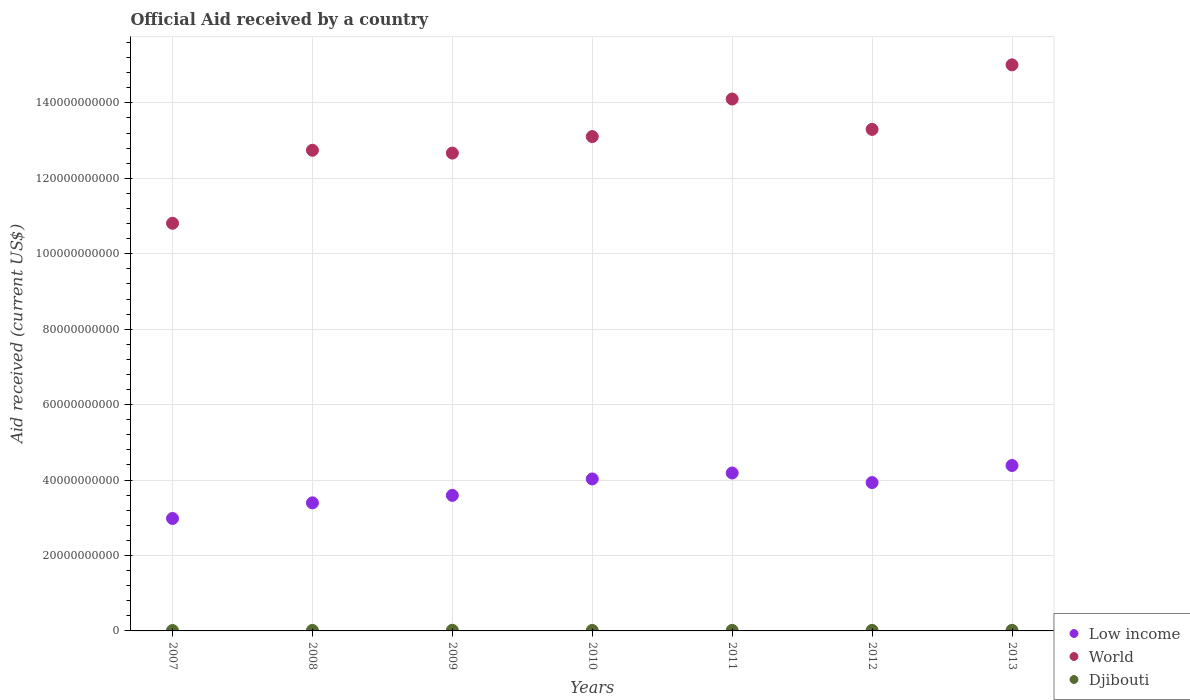How many different coloured dotlines are there?
Make the answer very short. 3. Is the number of dotlines equal to the number of legend labels?
Give a very brief answer. Yes. What is the net official aid received in World in 2012?
Provide a succinct answer. 1.33e+11. Across all years, what is the maximum net official aid received in World?
Your answer should be very brief. 1.50e+11. Across all years, what is the minimum net official aid received in Low income?
Your answer should be compact. 2.98e+1. What is the total net official aid received in World in the graph?
Offer a terse response. 9.17e+11. What is the difference between the net official aid received in World in 2008 and that in 2009?
Your response must be concise. 7.53e+08. What is the difference between the net official aid received in Djibouti in 2011 and the net official aid received in World in 2008?
Give a very brief answer. -1.27e+11. What is the average net official aid received in Djibouti per year?
Make the answer very short. 1.42e+08. In the year 2007, what is the difference between the net official aid received in Low income and net official aid received in Djibouti?
Offer a terse response. 2.97e+1. What is the ratio of the net official aid received in Low income in 2008 to that in 2009?
Your response must be concise. 0.94. Is the difference between the net official aid received in Low income in 2008 and 2012 greater than the difference between the net official aid received in Djibouti in 2008 and 2012?
Keep it short and to the point. No. What is the difference between the highest and the second highest net official aid received in World?
Provide a succinct answer. 9.06e+09. What is the difference between the highest and the lowest net official aid received in Low income?
Make the answer very short. 1.40e+1. Is the sum of the net official aid received in World in 2008 and 2011 greater than the maximum net official aid received in Low income across all years?
Your response must be concise. Yes. Is it the case that in every year, the sum of the net official aid received in Djibouti and net official aid received in Low income  is greater than the net official aid received in World?
Offer a very short reply. No. Is the net official aid received in Djibouti strictly greater than the net official aid received in World over the years?
Ensure brevity in your answer.  No. Is the net official aid received in Djibouti strictly less than the net official aid received in World over the years?
Give a very brief answer. Yes. How many dotlines are there?
Keep it short and to the point. 3. Are the values on the major ticks of Y-axis written in scientific E-notation?
Your answer should be compact. No. Does the graph contain any zero values?
Keep it short and to the point. No. Does the graph contain grids?
Provide a short and direct response. Yes. What is the title of the graph?
Your answer should be compact. Official Aid received by a country. Does "India" appear as one of the legend labels in the graph?
Offer a very short reply. No. What is the label or title of the X-axis?
Ensure brevity in your answer.  Years. What is the label or title of the Y-axis?
Offer a very short reply. Aid received (current US$). What is the Aid received (current US$) in Low income in 2007?
Keep it short and to the point. 2.98e+1. What is the Aid received (current US$) of World in 2007?
Make the answer very short. 1.08e+11. What is the Aid received (current US$) in Djibouti in 2007?
Your response must be concise. 1.13e+08. What is the Aid received (current US$) of Low income in 2008?
Keep it short and to the point. 3.40e+1. What is the Aid received (current US$) of World in 2008?
Keep it short and to the point. 1.27e+11. What is the Aid received (current US$) in Djibouti in 2008?
Offer a terse response. 1.41e+08. What is the Aid received (current US$) in Low income in 2009?
Provide a short and direct response. 3.59e+1. What is the Aid received (current US$) of World in 2009?
Offer a very short reply. 1.27e+11. What is the Aid received (current US$) in Djibouti in 2009?
Offer a terse response. 1.67e+08. What is the Aid received (current US$) of Low income in 2010?
Offer a very short reply. 4.03e+1. What is the Aid received (current US$) in World in 2010?
Provide a succinct answer. 1.31e+11. What is the Aid received (current US$) of Djibouti in 2010?
Keep it short and to the point. 1.32e+08. What is the Aid received (current US$) of Low income in 2011?
Offer a very short reply. 4.19e+1. What is the Aid received (current US$) in World in 2011?
Provide a short and direct response. 1.41e+11. What is the Aid received (current US$) of Djibouti in 2011?
Your response must be concise. 1.42e+08. What is the Aid received (current US$) in Low income in 2012?
Offer a terse response. 3.93e+1. What is the Aid received (current US$) of World in 2012?
Provide a short and direct response. 1.33e+11. What is the Aid received (current US$) in Djibouti in 2012?
Offer a terse response. 1.47e+08. What is the Aid received (current US$) of Low income in 2013?
Offer a very short reply. 4.39e+1. What is the Aid received (current US$) in World in 2013?
Provide a short and direct response. 1.50e+11. What is the Aid received (current US$) in Djibouti in 2013?
Offer a terse response. 1.53e+08. Across all years, what is the maximum Aid received (current US$) in Low income?
Provide a succinct answer. 4.39e+1. Across all years, what is the maximum Aid received (current US$) of World?
Your answer should be very brief. 1.50e+11. Across all years, what is the maximum Aid received (current US$) in Djibouti?
Keep it short and to the point. 1.67e+08. Across all years, what is the minimum Aid received (current US$) in Low income?
Ensure brevity in your answer.  2.98e+1. Across all years, what is the minimum Aid received (current US$) in World?
Provide a short and direct response. 1.08e+11. Across all years, what is the minimum Aid received (current US$) of Djibouti?
Provide a short and direct response. 1.13e+08. What is the total Aid received (current US$) of Low income in the graph?
Make the answer very short. 2.65e+11. What is the total Aid received (current US$) in World in the graph?
Your answer should be very brief. 9.17e+11. What is the total Aid received (current US$) in Djibouti in the graph?
Provide a succinct answer. 9.94e+08. What is the difference between the Aid received (current US$) of Low income in 2007 and that in 2008?
Your answer should be compact. -4.14e+09. What is the difference between the Aid received (current US$) of World in 2007 and that in 2008?
Your response must be concise. -1.94e+1. What is the difference between the Aid received (current US$) of Djibouti in 2007 and that in 2008?
Offer a terse response. -2.82e+07. What is the difference between the Aid received (current US$) of Low income in 2007 and that in 2009?
Give a very brief answer. -6.13e+09. What is the difference between the Aid received (current US$) in World in 2007 and that in 2009?
Your response must be concise. -1.86e+1. What is the difference between the Aid received (current US$) of Djibouti in 2007 and that in 2009?
Make the answer very short. -5.41e+07. What is the difference between the Aid received (current US$) in Low income in 2007 and that in 2010?
Offer a terse response. -1.05e+1. What is the difference between the Aid received (current US$) of World in 2007 and that in 2010?
Your answer should be compact. -2.30e+1. What is the difference between the Aid received (current US$) of Djibouti in 2007 and that in 2010?
Provide a succinct answer. -1.96e+07. What is the difference between the Aid received (current US$) in Low income in 2007 and that in 2011?
Provide a succinct answer. -1.21e+1. What is the difference between the Aid received (current US$) in World in 2007 and that in 2011?
Give a very brief answer. -3.29e+1. What is the difference between the Aid received (current US$) of Djibouti in 2007 and that in 2011?
Keep it short and to the point. -2.91e+07. What is the difference between the Aid received (current US$) of Low income in 2007 and that in 2012?
Provide a succinct answer. -9.52e+09. What is the difference between the Aid received (current US$) of World in 2007 and that in 2012?
Provide a short and direct response. -2.49e+1. What is the difference between the Aid received (current US$) of Djibouti in 2007 and that in 2012?
Offer a very short reply. -3.40e+07. What is the difference between the Aid received (current US$) of Low income in 2007 and that in 2013?
Your answer should be compact. -1.40e+1. What is the difference between the Aid received (current US$) in World in 2007 and that in 2013?
Offer a terse response. -4.20e+1. What is the difference between the Aid received (current US$) in Djibouti in 2007 and that in 2013?
Your response must be concise. -4.03e+07. What is the difference between the Aid received (current US$) in Low income in 2008 and that in 2009?
Make the answer very short. -1.98e+09. What is the difference between the Aid received (current US$) of World in 2008 and that in 2009?
Keep it short and to the point. 7.53e+08. What is the difference between the Aid received (current US$) in Djibouti in 2008 and that in 2009?
Offer a terse response. -2.59e+07. What is the difference between the Aid received (current US$) of Low income in 2008 and that in 2010?
Offer a terse response. -6.34e+09. What is the difference between the Aid received (current US$) in World in 2008 and that in 2010?
Keep it short and to the point. -3.63e+09. What is the difference between the Aid received (current US$) of Djibouti in 2008 and that in 2010?
Give a very brief answer. 8.58e+06. What is the difference between the Aid received (current US$) in Low income in 2008 and that in 2011?
Provide a short and direct response. -7.92e+09. What is the difference between the Aid received (current US$) of World in 2008 and that in 2011?
Your response must be concise. -1.36e+1. What is the difference between the Aid received (current US$) in Djibouti in 2008 and that in 2011?
Ensure brevity in your answer.  -9.30e+05. What is the difference between the Aid received (current US$) in Low income in 2008 and that in 2012?
Ensure brevity in your answer.  -5.38e+09. What is the difference between the Aid received (current US$) of World in 2008 and that in 2012?
Ensure brevity in your answer.  -5.53e+09. What is the difference between the Aid received (current US$) in Djibouti in 2008 and that in 2012?
Your answer should be compact. -5.77e+06. What is the difference between the Aid received (current US$) of Low income in 2008 and that in 2013?
Provide a succinct answer. -9.90e+09. What is the difference between the Aid received (current US$) in World in 2008 and that in 2013?
Provide a succinct answer. -2.26e+1. What is the difference between the Aid received (current US$) in Djibouti in 2008 and that in 2013?
Your answer should be compact. -1.21e+07. What is the difference between the Aid received (current US$) in Low income in 2009 and that in 2010?
Offer a very short reply. -4.36e+09. What is the difference between the Aid received (current US$) in World in 2009 and that in 2010?
Provide a succinct answer. -4.38e+09. What is the difference between the Aid received (current US$) of Djibouti in 2009 and that in 2010?
Ensure brevity in your answer.  3.45e+07. What is the difference between the Aid received (current US$) in Low income in 2009 and that in 2011?
Ensure brevity in your answer.  -5.94e+09. What is the difference between the Aid received (current US$) of World in 2009 and that in 2011?
Offer a very short reply. -1.43e+1. What is the difference between the Aid received (current US$) in Djibouti in 2009 and that in 2011?
Offer a very short reply. 2.50e+07. What is the difference between the Aid received (current US$) of Low income in 2009 and that in 2012?
Your answer should be compact. -3.39e+09. What is the difference between the Aid received (current US$) in World in 2009 and that in 2012?
Offer a terse response. -6.29e+09. What is the difference between the Aid received (current US$) in Djibouti in 2009 and that in 2012?
Offer a very short reply. 2.01e+07. What is the difference between the Aid received (current US$) of Low income in 2009 and that in 2013?
Make the answer very short. -7.92e+09. What is the difference between the Aid received (current US$) in World in 2009 and that in 2013?
Provide a short and direct response. -2.34e+1. What is the difference between the Aid received (current US$) of Djibouti in 2009 and that in 2013?
Provide a short and direct response. 1.38e+07. What is the difference between the Aid received (current US$) of Low income in 2010 and that in 2011?
Offer a terse response. -1.58e+09. What is the difference between the Aid received (current US$) of World in 2010 and that in 2011?
Your answer should be very brief. -9.96e+09. What is the difference between the Aid received (current US$) of Djibouti in 2010 and that in 2011?
Your answer should be very brief. -9.51e+06. What is the difference between the Aid received (current US$) of Low income in 2010 and that in 2012?
Give a very brief answer. 9.64e+08. What is the difference between the Aid received (current US$) in World in 2010 and that in 2012?
Your answer should be compact. -1.91e+09. What is the difference between the Aid received (current US$) of Djibouti in 2010 and that in 2012?
Ensure brevity in your answer.  -1.44e+07. What is the difference between the Aid received (current US$) of Low income in 2010 and that in 2013?
Your answer should be compact. -3.56e+09. What is the difference between the Aid received (current US$) of World in 2010 and that in 2013?
Your answer should be compact. -1.90e+1. What is the difference between the Aid received (current US$) in Djibouti in 2010 and that in 2013?
Your response must be concise. -2.07e+07. What is the difference between the Aid received (current US$) of Low income in 2011 and that in 2012?
Offer a very short reply. 2.54e+09. What is the difference between the Aid received (current US$) in World in 2011 and that in 2012?
Keep it short and to the point. 8.05e+09. What is the difference between the Aid received (current US$) of Djibouti in 2011 and that in 2012?
Keep it short and to the point. -4.84e+06. What is the difference between the Aid received (current US$) of Low income in 2011 and that in 2013?
Offer a terse response. -1.98e+09. What is the difference between the Aid received (current US$) of World in 2011 and that in 2013?
Provide a short and direct response. -9.06e+09. What is the difference between the Aid received (current US$) in Djibouti in 2011 and that in 2013?
Provide a succinct answer. -1.12e+07. What is the difference between the Aid received (current US$) in Low income in 2012 and that in 2013?
Provide a short and direct response. -4.52e+09. What is the difference between the Aid received (current US$) of World in 2012 and that in 2013?
Provide a succinct answer. -1.71e+1. What is the difference between the Aid received (current US$) of Djibouti in 2012 and that in 2013?
Offer a very short reply. -6.36e+06. What is the difference between the Aid received (current US$) in Low income in 2007 and the Aid received (current US$) in World in 2008?
Keep it short and to the point. -9.76e+1. What is the difference between the Aid received (current US$) in Low income in 2007 and the Aid received (current US$) in Djibouti in 2008?
Make the answer very short. 2.97e+1. What is the difference between the Aid received (current US$) in World in 2007 and the Aid received (current US$) in Djibouti in 2008?
Offer a terse response. 1.08e+11. What is the difference between the Aid received (current US$) of Low income in 2007 and the Aid received (current US$) of World in 2009?
Your answer should be very brief. -9.69e+1. What is the difference between the Aid received (current US$) of Low income in 2007 and the Aid received (current US$) of Djibouti in 2009?
Make the answer very short. 2.96e+1. What is the difference between the Aid received (current US$) of World in 2007 and the Aid received (current US$) of Djibouti in 2009?
Offer a terse response. 1.08e+11. What is the difference between the Aid received (current US$) in Low income in 2007 and the Aid received (current US$) in World in 2010?
Your answer should be compact. -1.01e+11. What is the difference between the Aid received (current US$) in Low income in 2007 and the Aid received (current US$) in Djibouti in 2010?
Provide a short and direct response. 2.97e+1. What is the difference between the Aid received (current US$) in World in 2007 and the Aid received (current US$) in Djibouti in 2010?
Offer a terse response. 1.08e+11. What is the difference between the Aid received (current US$) of Low income in 2007 and the Aid received (current US$) of World in 2011?
Offer a terse response. -1.11e+11. What is the difference between the Aid received (current US$) in Low income in 2007 and the Aid received (current US$) in Djibouti in 2011?
Your response must be concise. 2.97e+1. What is the difference between the Aid received (current US$) in World in 2007 and the Aid received (current US$) in Djibouti in 2011?
Provide a short and direct response. 1.08e+11. What is the difference between the Aid received (current US$) of Low income in 2007 and the Aid received (current US$) of World in 2012?
Offer a terse response. -1.03e+11. What is the difference between the Aid received (current US$) of Low income in 2007 and the Aid received (current US$) of Djibouti in 2012?
Your answer should be very brief. 2.97e+1. What is the difference between the Aid received (current US$) of World in 2007 and the Aid received (current US$) of Djibouti in 2012?
Keep it short and to the point. 1.08e+11. What is the difference between the Aid received (current US$) in Low income in 2007 and the Aid received (current US$) in World in 2013?
Provide a short and direct response. -1.20e+11. What is the difference between the Aid received (current US$) in Low income in 2007 and the Aid received (current US$) in Djibouti in 2013?
Ensure brevity in your answer.  2.97e+1. What is the difference between the Aid received (current US$) of World in 2007 and the Aid received (current US$) of Djibouti in 2013?
Ensure brevity in your answer.  1.08e+11. What is the difference between the Aid received (current US$) in Low income in 2008 and the Aid received (current US$) in World in 2009?
Offer a terse response. -9.27e+1. What is the difference between the Aid received (current US$) in Low income in 2008 and the Aid received (current US$) in Djibouti in 2009?
Make the answer very short. 3.38e+1. What is the difference between the Aid received (current US$) of World in 2008 and the Aid received (current US$) of Djibouti in 2009?
Your answer should be very brief. 1.27e+11. What is the difference between the Aid received (current US$) of Low income in 2008 and the Aid received (current US$) of World in 2010?
Your response must be concise. -9.71e+1. What is the difference between the Aid received (current US$) of Low income in 2008 and the Aid received (current US$) of Djibouti in 2010?
Make the answer very short. 3.38e+1. What is the difference between the Aid received (current US$) in World in 2008 and the Aid received (current US$) in Djibouti in 2010?
Make the answer very short. 1.27e+11. What is the difference between the Aid received (current US$) in Low income in 2008 and the Aid received (current US$) in World in 2011?
Your response must be concise. -1.07e+11. What is the difference between the Aid received (current US$) in Low income in 2008 and the Aid received (current US$) in Djibouti in 2011?
Provide a short and direct response. 3.38e+1. What is the difference between the Aid received (current US$) in World in 2008 and the Aid received (current US$) in Djibouti in 2011?
Keep it short and to the point. 1.27e+11. What is the difference between the Aid received (current US$) of Low income in 2008 and the Aid received (current US$) of World in 2012?
Offer a very short reply. -9.90e+1. What is the difference between the Aid received (current US$) in Low income in 2008 and the Aid received (current US$) in Djibouti in 2012?
Your response must be concise. 3.38e+1. What is the difference between the Aid received (current US$) of World in 2008 and the Aid received (current US$) of Djibouti in 2012?
Your answer should be compact. 1.27e+11. What is the difference between the Aid received (current US$) in Low income in 2008 and the Aid received (current US$) in World in 2013?
Ensure brevity in your answer.  -1.16e+11. What is the difference between the Aid received (current US$) in Low income in 2008 and the Aid received (current US$) in Djibouti in 2013?
Keep it short and to the point. 3.38e+1. What is the difference between the Aid received (current US$) in World in 2008 and the Aid received (current US$) in Djibouti in 2013?
Make the answer very short. 1.27e+11. What is the difference between the Aid received (current US$) in Low income in 2009 and the Aid received (current US$) in World in 2010?
Ensure brevity in your answer.  -9.51e+1. What is the difference between the Aid received (current US$) in Low income in 2009 and the Aid received (current US$) in Djibouti in 2010?
Offer a terse response. 3.58e+1. What is the difference between the Aid received (current US$) in World in 2009 and the Aid received (current US$) in Djibouti in 2010?
Ensure brevity in your answer.  1.27e+11. What is the difference between the Aid received (current US$) in Low income in 2009 and the Aid received (current US$) in World in 2011?
Provide a succinct answer. -1.05e+11. What is the difference between the Aid received (current US$) in Low income in 2009 and the Aid received (current US$) in Djibouti in 2011?
Make the answer very short. 3.58e+1. What is the difference between the Aid received (current US$) of World in 2009 and the Aid received (current US$) of Djibouti in 2011?
Provide a succinct answer. 1.27e+11. What is the difference between the Aid received (current US$) in Low income in 2009 and the Aid received (current US$) in World in 2012?
Give a very brief answer. -9.70e+1. What is the difference between the Aid received (current US$) of Low income in 2009 and the Aid received (current US$) of Djibouti in 2012?
Your answer should be compact. 3.58e+1. What is the difference between the Aid received (current US$) of World in 2009 and the Aid received (current US$) of Djibouti in 2012?
Provide a succinct answer. 1.27e+11. What is the difference between the Aid received (current US$) of Low income in 2009 and the Aid received (current US$) of World in 2013?
Give a very brief answer. -1.14e+11. What is the difference between the Aid received (current US$) in Low income in 2009 and the Aid received (current US$) in Djibouti in 2013?
Your answer should be very brief. 3.58e+1. What is the difference between the Aid received (current US$) in World in 2009 and the Aid received (current US$) in Djibouti in 2013?
Provide a succinct answer. 1.27e+11. What is the difference between the Aid received (current US$) in Low income in 2010 and the Aid received (current US$) in World in 2011?
Ensure brevity in your answer.  -1.01e+11. What is the difference between the Aid received (current US$) in Low income in 2010 and the Aid received (current US$) in Djibouti in 2011?
Your answer should be compact. 4.02e+1. What is the difference between the Aid received (current US$) of World in 2010 and the Aid received (current US$) of Djibouti in 2011?
Your response must be concise. 1.31e+11. What is the difference between the Aid received (current US$) of Low income in 2010 and the Aid received (current US$) of World in 2012?
Keep it short and to the point. -9.27e+1. What is the difference between the Aid received (current US$) in Low income in 2010 and the Aid received (current US$) in Djibouti in 2012?
Your answer should be very brief. 4.02e+1. What is the difference between the Aid received (current US$) of World in 2010 and the Aid received (current US$) of Djibouti in 2012?
Ensure brevity in your answer.  1.31e+11. What is the difference between the Aid received (current US$) in Low income in 2010 and the Aid received (current US$) in World in 2013?
Make the answer very short. -1.10e+11. What is the difference between the Aid received (current US$) of Low income in 2010 and the Aid received (current US$) of Djibouti in 2013?
Your response must be concise. 4.01e+1. What is the difference between the Aid received (current US$) in World in 2010 and the Aid received (current US$) in Djibouti in 2013?
Keep it short and to the point. 1.31e+11. What is the difference between the Aid received (current US$) of Low income in 2011 and the Aid received (current US$) of World in 2012?
Ensure brevity in your answer.  -9.11e+1. What is the difference between the Aid received (current US$) in Low income in 2011 and the Aid received (current US$) in Djibouti in 2012?
Your answer should be compact. 4.17e+1. What is the difference between the Aid received (current US$) in World in 2011 and the Aid received (current US$) in Djibouti in 2012?
Keep it short and to the point. 1.41e+11. What is the difference between the Aid received (current US$) of Low income in 2011 and the Aid received (current US$) of World in 2013?
Ensure brevity in your answer.  -1.08e+11. What is the difference between the Aid received (current US$) of Low income in 2011 and the Aid received (current US$) of Djibouti in 2013?
Offer a very short reply. 4.17e+1. What is the difference between the Aid received (current US$) of World in 2011 and the Aid received (current US$) of Djibouti in 2013?
Give a very brief answer. 1.41e+11. What is the difference between the Aid received (current US$) of Low income in 2012 and the Aid received (current US$) of World in 2013?
Your answer should be compact. -1.11e+11. What is the difference between the Aid received (current US$) in Low income in 2012 and the Aid received (current US$) in Djibouti in 2013?
Give a very brief answer. 3.92e+1. What is the difference between the Aid received (current US$) in World in 2012 and the Aid received (current US$) in Djibouti in 2013?
Ensure brevity in your answer.  1.33e+11. What is the average Aid received (current US$) of Low income per year?
Provide a succinct answer. 3.79e+1. What is the average Aid received (current US$) of World per year?
Your answer should be compact. 1.31e+11. What is the average Aid received (current US$) of Djibouti per year?
Your response must be concise. 1.42e+08. In the year 2007, what is the difference between the Aid received (current US$) in Low income and Aid received (current US$) in World?
Offer a terse response. -7.83e+1. In the year 2007, what is the difference between the Aid received (current US$) in Low income and Aid received (current US$) in Djibouti?
Your answer should be very brief. 2.97e+1. In the year 2007, what is the difference between the Aid received (current US$) of World and Aid received (current US$) of Djibouti?
Provide a short and direct response. 1.08e+11. In the year 2008, what is the difference between the Aid received (current US$) of Low income and Aid received (current US$) of World?
Give a very brief answer. -9.35e+1. In the year 2008, what is the difference between the Aid received (current US$) of Low income and Aid received (current US$) of Djibouti?
Give a very brief answer. 3.38e+1. In the year 2008, what is the difference between the Aid received (current US$) of World and Aid received (current US$) of Djibouti?
Provide a short and direct response. 1.27e+11. In the year 2009, what is the difference between the Aid received (current US$) in Low income and Aid received (current US$) in World?
Your response must be concise. -9.08e+1. In the year 2009, what is the difference between the Aid received (current US$) in Low income and Aid received (current US$) in Djibouti?
Keep it short and to the point. 3.58e+1. In the year 2009, what is the difference between the Aid received (current US$) in World and Aid received (current US$) in Djibouti?
Provide a short and direct response. 1.27e+11. In the year 2010, what is the difference between the Aid received (current US$) of Low income and Aid received (current US$) of World?
Offer a terse response. -9.08e+1. In the year 2010, what is the difference between the Aid received (current US$) of Low income and Aid received (current US$) of Djibouti?
Give a very brief answer. 4.02e+1. In the year 2010, what is the difference between the Aid received (current US$) in World and Aid received (current US$) in Djibouti?
Ensure brevity in your answer.  1.31e+11. In the year 2011, what is the difference between the Aid received (current US$) of Low income and Aid received (current US$) of World?
Your answer should be compact. -9.92e+1. In the year 2011, what is the difference between the Aid received (current US$) of Low income and Aid received (current US$) of Djibouti?
Provide a succinct answer. 4.17e+1. In the year 2011, what is the difference between the Aid received (current US$) of World and Aid received (current US$) of Djibouti?
Keep it short and to the point. 1.41e+11. In the year 2012, what is the difference between the Aid received (current US$) of Low income and Aid received (current US$) of World?
Keep it short and to the point. -9.36e+1. In the year 2012, what is the difference between the Aid received (current US$) in Low income and Aid received (current US$) in Djibouti?
Your answer should be very brief. 3.92e+1. In the year 2012, what is the difference between the Aid received (current US$) of World and Aid received (current US$) of Djibouti?
Ensure brevity in your answer.  1.33e+11. In the year 2013, what is the difference between the Aid received (current US$) of Low income and Aid received (current US$) of World?
Offer a very short reply. -1.06e+11. In the year 2013, what is the difference between the Aid received (current US$) in Low income and Aid received (current US$) in Djibouti?
Your response must be concise. 4.37e+1. In the year 2013, what is the difference between the Aid received (current US$) of World and Aid received (current US$) of Djibouti?
Your answer should be very brief. 1.50e+11. What is the ratio of the Aid received (current US$) in Low income in 2007 to that in 2008?
Your response must be concise. 0.88. What is the ratio of the Aid received (current US$) of World in 2007 to that in 2008?
Your response must be concise. 0.85. What is the ratio of the Aid received (current US$) of Djibouti in 2007 to that in 2008?
Provide a succinct answer. 0.8. What is the ratio of the Aid received (current US$) in Low income in 2007 to that in 2009?
Your answer should be compact. 0.83. What is the ratio of the Aid received (current US$) in World in 2007 to that in 2009?
Ensure brevity in your answer.  0.85. What is the ratio of the Aid received (current US$) of Djibouti in 2007 to that in 2009?
Your answer should be compact. 0.68. What is the ratio of the Aid received (current US$) of Low income in 2007 to that in 2010?
Provide a succinct answer. 0.74. What is the ratio of the Aid received (current US$) in World in 2007 to that in 2010?
Keep it short and to the point. 0.82. What is the ratio of the Aid received (current US$) in Djibouti in 2007 to that in 2010?
Provide a succinct answer. 0.85. What is the ratio of the Aid received (current US$) in Low income in 2007 to that in 2011?
Your answer should be compact. 0.71. What is the ratio of the Aid received (current US$) of World in 2007 to that in 2011?
Provide a short and direct response. 0.77. What is the ratio of the Aid received (current US$) in Djibouti in 2007 to that in 2011?
Give a very brief answer. 0.79. What is the ratio of the Aid received (current US$) in Low income in 2007 to that in 2012?
Make the answer very short. 0.76. What is the ratio of the Aid received (current US$) of World in 2007 to that in 2012?
Keep it short and to the point. 0.81. What is the ratio of the Aid received (current US$) in Djibouti in 2007 to that in 2012?
Your answer should be compact. 0.77. What is the ratio of the Aid received (current US$) of Low income in 2007 to that in 2013?
Ensure brevity in your answer.  0.68. What is the ratio of the Aid received (current US$) of World in 2007 to that in 2013?
Keep it short and to the point. 0.72. What is the ratio of the Aid received (current US$) in Djibouti in 2007 to that in 2013?
Your answer should be compact. 0.74. What is the ratio of the Aid received (current US$) in Low income in 2008 to that in 2009?
Provide a short and direct response. 0.94. What is the ratio of the Aid received (current US$) of World in 2008 to that in 2009?
Keep it short and to the point. 1.01. What is the ratio of the Aid received (current US$) in Djibouti in 2008 to that in 2009?
Provide a short and direct response. 0.84. What is the ratio of the Aid received (current US$) in Low income in 2008 to that in 2010?
Offer a terse response. 0.84. What is the ratio of the Aid received (current US$) in World in 2008 to that in 2010?
Offer a very short reply. 0.97. What is the ratio of the Aid received (current US$) in Djibouti in 2008 to that in 2010?
Give a very brief answer. 1.06. What is the ratio of the Aid received (current US$) in Low income in 2008 to that in 2011?
Provide a succinct answer. 0.81. What is the ratio of the Aid received (current US$) of World in 2008 to that in 2011?
Make the answer very short. 0.9. What is the ratio of the Aid received (current US$) in Djibouti in 2008 to that in 2011?
Give a very brief answer. 0.99. What is the ratio of the Aid received (current US$) in Low income in 2008 to that in 2012?
Your answer should be compact. 0.86. What is the ratio of the Aid received (current US$) in World in 2008 to that in 2012?
Give a very brief answer. 0.96. What is the ratio of the Aid received (current US$) in Djibouti in 2008 to that in 2012?
Ensure brevity in your answer.  0.96. What is the ratio of the Aid received (current US$) in Low income in 2008 to that in 2013?
Ensure brevity in your answer.  0.77. What is the ratio of the Aid received (current US$) of World in 2008 to that in 2013?
Ensure brevity in your answer.  0.85. What is the ratio of the Aid received (current US$) of Djibouti in 2008 to that in 2013?
Offer a terse response. 0.92. What is the ratio of the Aid received (current US$) of Low income in 2009 to that in 2010?
Give a very brief answer. 0.89. What is the ratio of the Aid received (current US$) of World in 2009 to that in 2010?
Your answer should be very brief. 0.97. What is the ratio of the Aid received (current US$) of Djibouti in 2009 to that in 2010?
Make the answer very short. 1.26. What is the ratio of the Aid received (current US$) in Low income in 2009 to that in 2011?
Offer a terse response. 0.86. What is the ratio of the Aid received (current US$) in World in 2009 to that in 2011?
Offer a very short reply. 0.9. What is the ratio of the Aid received (current US$) in Djibouti in 2009 to that in 2011?
Ensure brevity in your answer.  1.18. What is the ratio of the Aid received (current US$) of Low income in 2009 to that in 2012?
Provide a short and direct response. 0.91. What is the ratio of the Aid received (current US$) of World in 2009 to that in 2012?
Provide a short and direct response. 0.95. What is the ratio of the Aid received (current US$) of Djibouti in 2009 to that in 2012?
Your response must be concise. 1.14. What is the ratio of the Aid received (current US$) in Low income in 2009 to that in 2013?
Offer a very short reply. 0.82. What is the ratio of the Aid received (current US$) of World in 2009 to that in 2013?
Ensure brevity in your answer.  0.84. What is the ratio of the Aid received (current US$) in Djibouti in 2009 to that in 2013?
Provide a succinct answer. 1.09. What is the ratio of the Aid received (current US$) in Low income in 2010 to that in 2011?
Offer a terse response. 0.96. What is the ratio of the Aid received (current US$) in World in 2010 to that in 2011?
Provide a succinct answer. 0.93. What is the ratio of the Aid received (current US$) in Djibouti in 2010 to that in 2011?
Make the answer very short. 0.93. What is the ratio of the Aid received (current US$) of Low income in 2010 to that in 2012?
Your answer should be compact. 1.02. What is the ratio of the Aid received (current US$) in World in 2010 to that in 2012?
Your answer should be compact. 0.99. What is the ratio of the Aid received (current US$) of Djibouti in 2010 to that in 2012?
Provide a short and direct response. 0.9. What is the ratio of the Aid received (current US$) of Low income in 2010 to that in 2013?
Your answer should be very brief. 0.92. What is the ratio of the Aid received (current US$) of World in 2010 to that in 2013?
Make the answer very short. 0.87. What is the ratio of the Aid received (current US$) in Djibouti in 2010 to that in 2013?
Offer a terse response. 0.86. What is the ratio of the Aid received (current US$) of Low income in 2011 to that in 2012?
Give a very brief answer. 1.06. What is the ratio of the Aid received (current US$) in World in 2011 to that in 2012?
Your answer should be compact. 1.06. What is the ratio of the Aid received (current US$) of Low income in 2011 to that in 2013?
Offer a terse response. 0.95. What is the ratio of the Aid received (current US$) of World in 2011 to that in 2013?
Give a very brief answer. 0.94. What is the ratio of the Aid received (current US$) in Djibouti in 2011 to that in 2013?
Keep it short and to the point. 0.93. What is the ratio of the Aid received (current US$) of Low income in 2012 to that in 2013?
Offer a very short reply. 0.9. What is the ratio of the Aid received (current US$) in World in 2012 to that in 2013?
Offer a terse response. 0.89. What is the ratio of the Aid received (current US$) of Djibouti in 2012 to that in 2013?
Your answer should be very brief. 0.96. What is the difference between the highest and the second highest Aid received (current US$) in Low income?
Give a very brief answer. 1.98e+09. What is the difference between the highest and the second highest Aid received (current US$) of World?
Keep it short and to the point. 9.06e+09. What is the difference between the highest and the second highest Aid received (current US$) of Djibouti?
Give a very brief answer. 1.38e+07. What is the difference between the highest and the lowest Aid received (current US$) in Low income?
Offer a terse response. 1.40e+1. What is the difference between the highest and the lowest Aid received (current US$) of World?
Your answer should be compact. 4.20e+1. What is the difference between the highest and the lowest Aid received (current US$) of Djibouti?
Provide a short and direct response. 5.41e+07. 